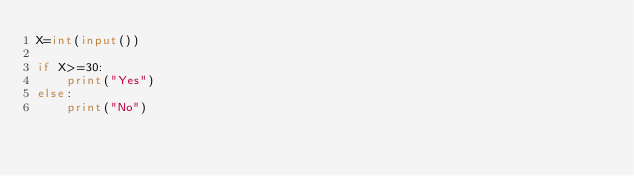<code> <loc_0><loc_0><loc_500><loc_500><_Python_>X=int(input())

if X>=30:
    print("Yes")
else:
    print("No")</code> 